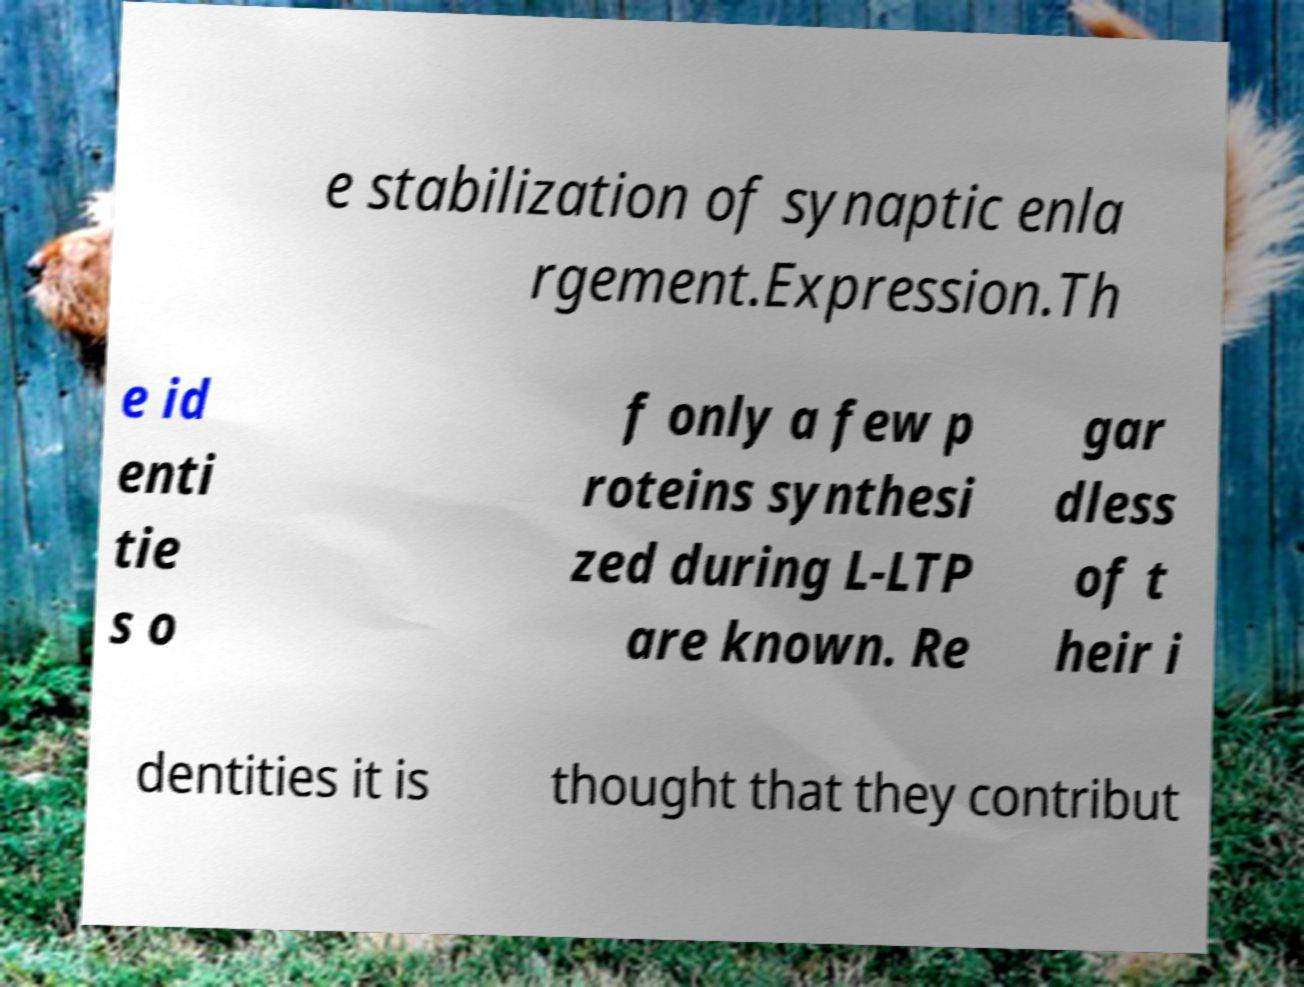Could you assist in decoding the text presented in this image and type it out clearly? e stabilization of synaptic enla rgement.Expression.Th e id enti tie s o f only a few p roteins synthesi zed during L-LTP are known. Re gar dless of t heir i dentities it is thought that they contribut 